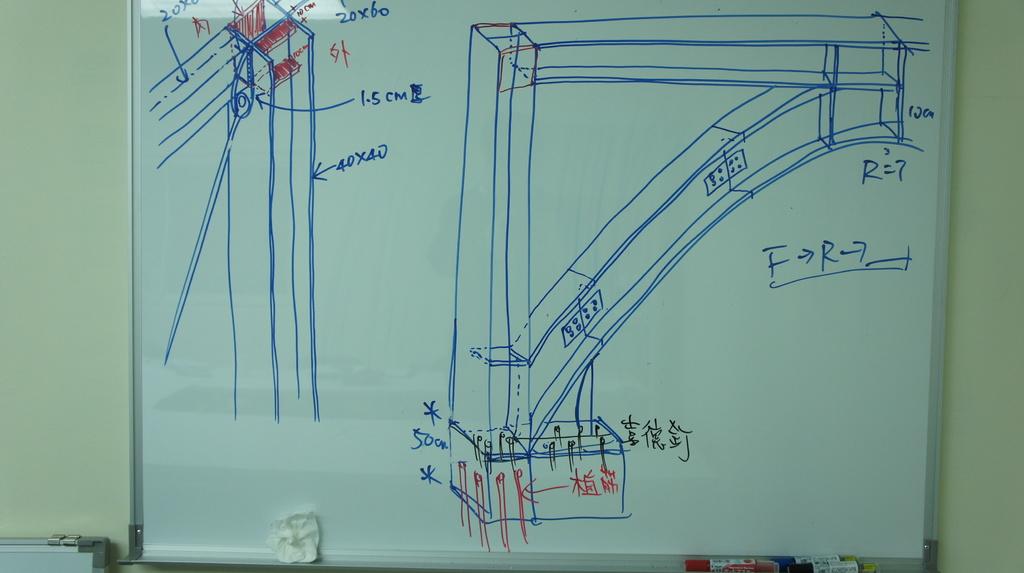What equals 7?
Offer a terse response. R. What unit of measurement is used?
Your answer should be compact. Cm. 